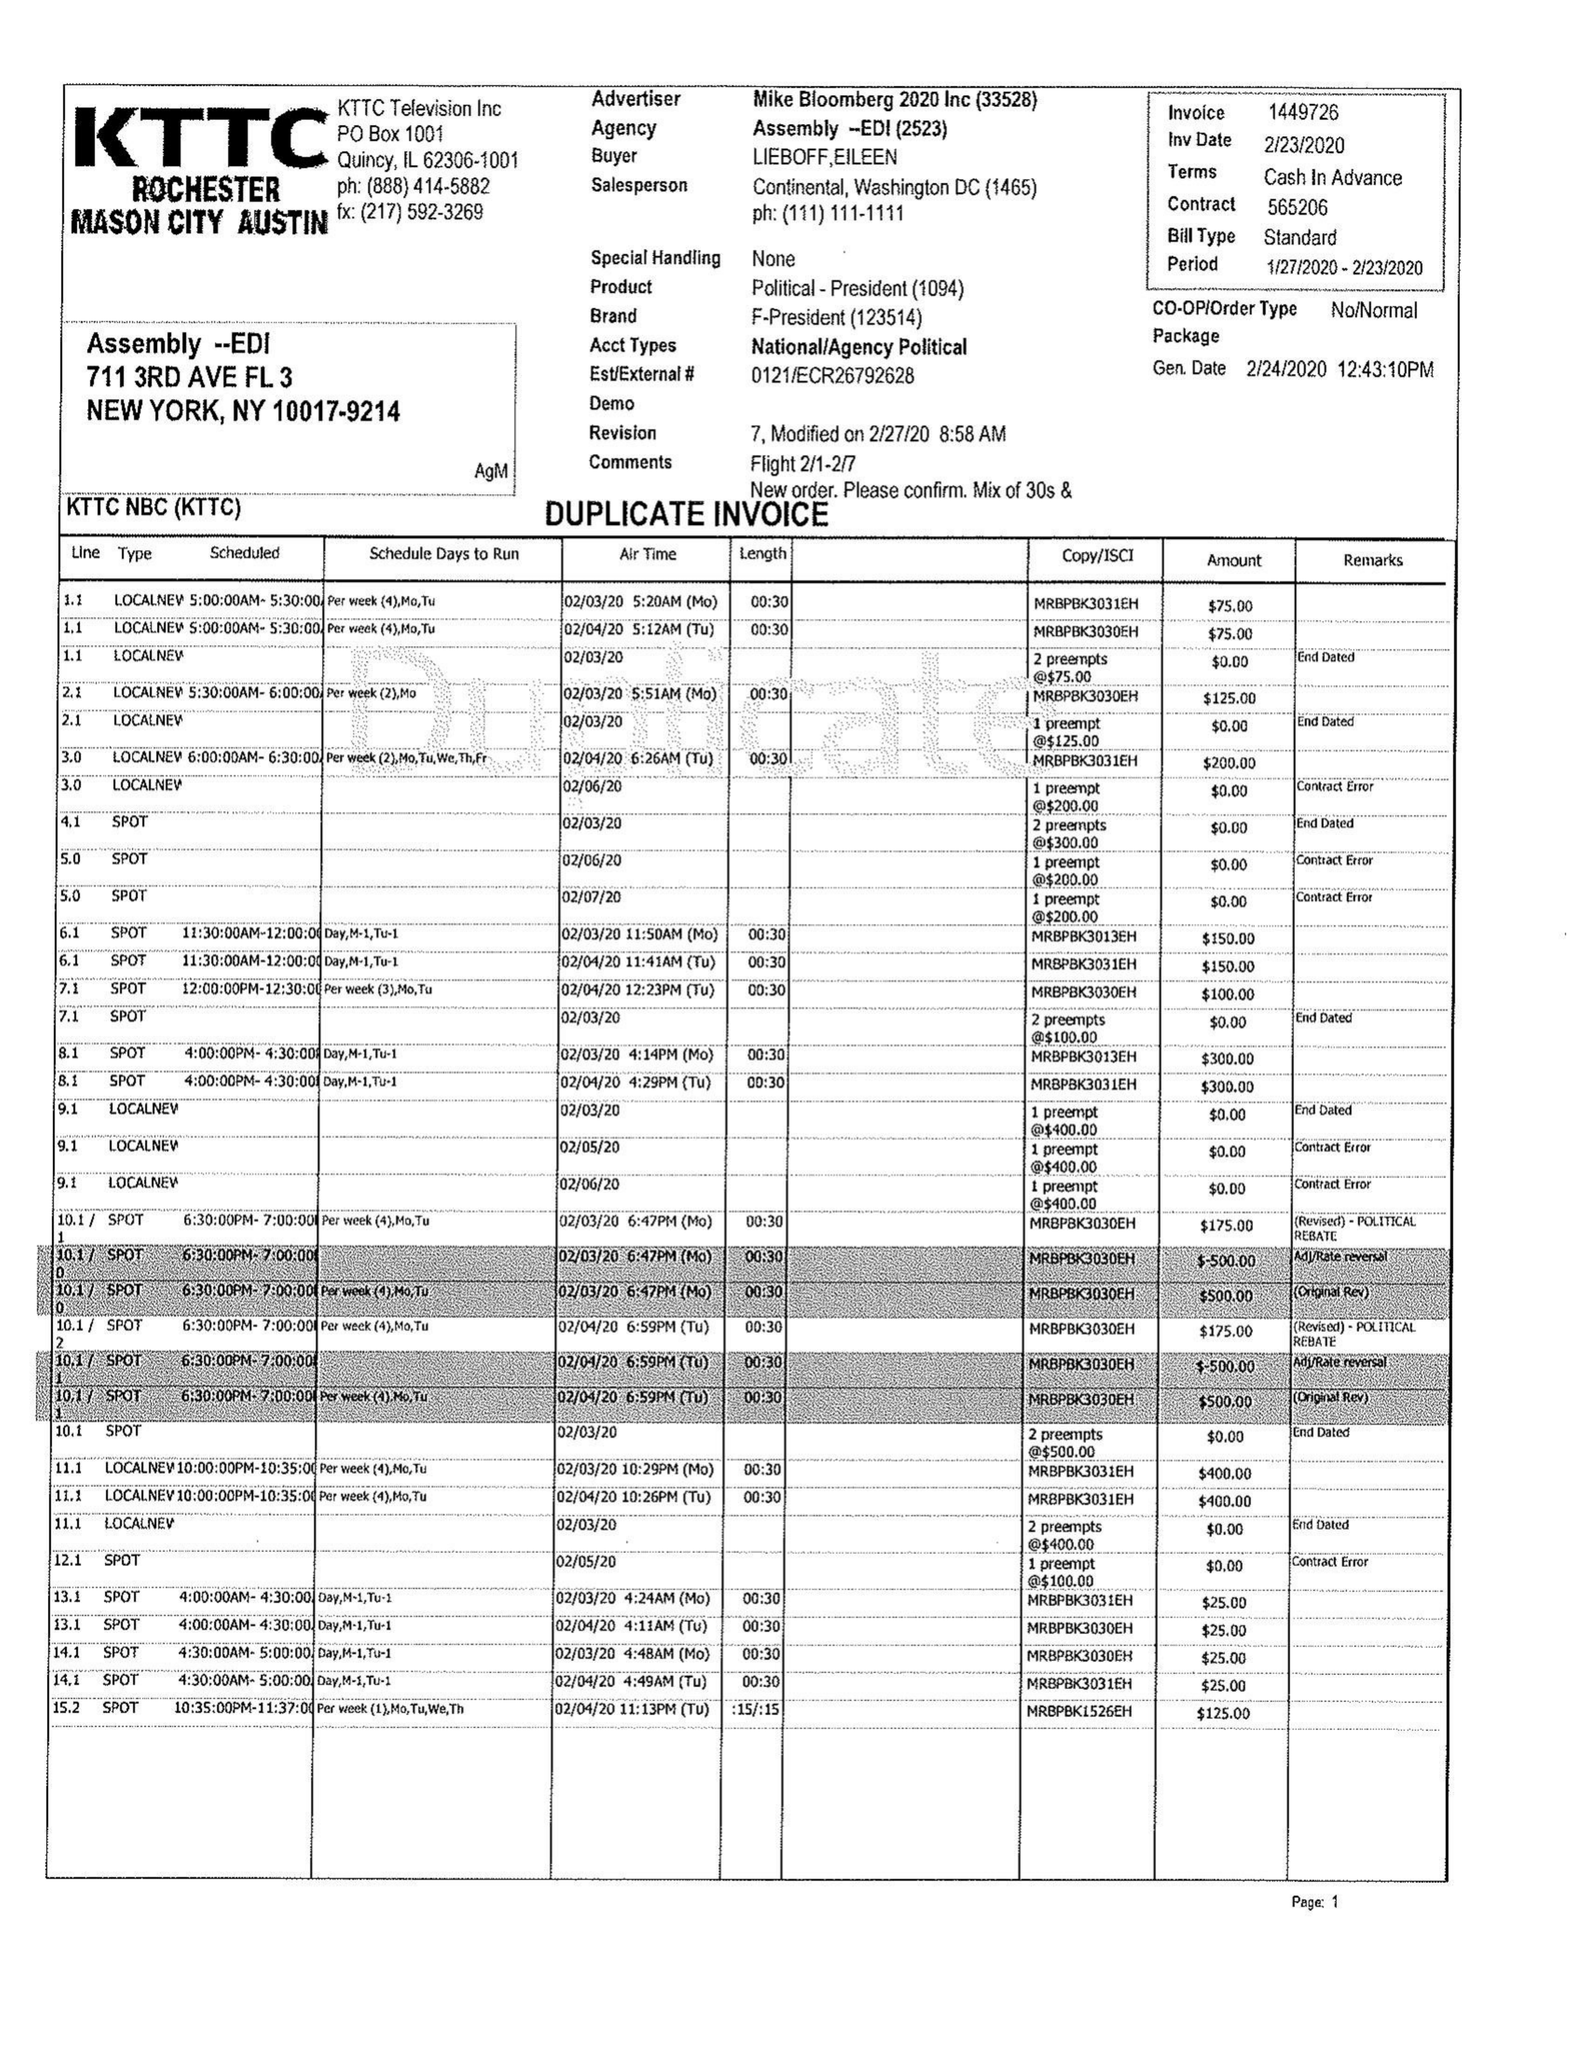What is the value for the gross_amount?
Answer the question using a single word or phrase. 11100.00 